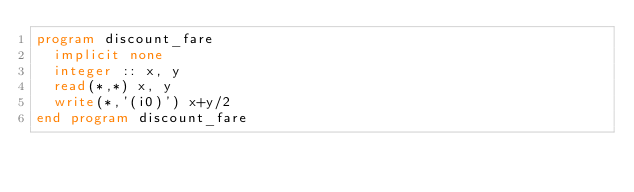Convert code to text. <code><loc_0><loc_0><loc_500><loc_500><_FORTRAN_>program discount_fare
  implicit none
  integer :: x, y
  read(*,*) x, y
  write(*,'(i0)') x+y/2
end program discount_fare</code> 